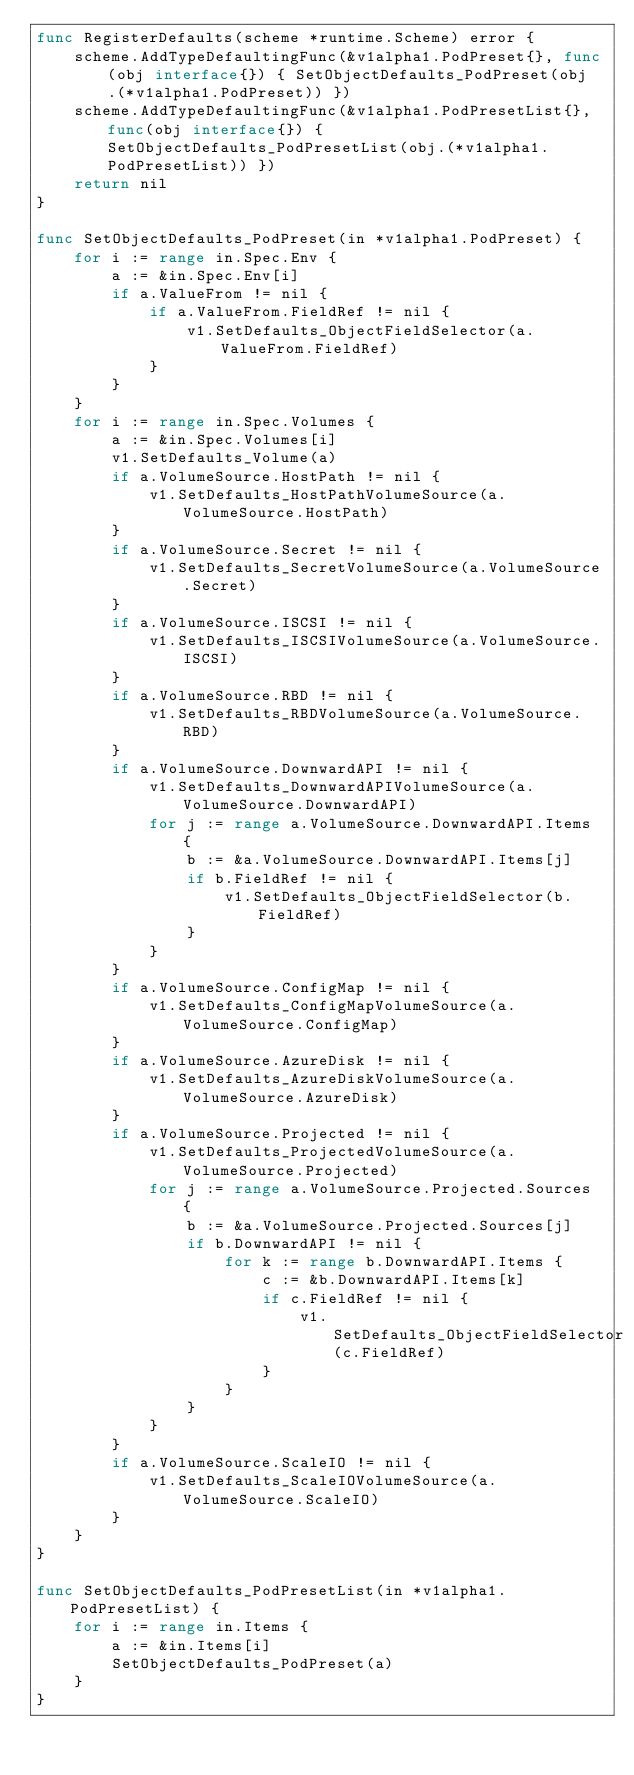Convert code to text. <code><loc_0><loc_0><loc_500><loc_500><_Go_>func RegisterDefaults(scheme *runtime.Scheme) error {
	scheme.AddTypeDefaultingFunc(&v1alpha1.PodPreset{}, func(obj interface{}) { SetObjectDefaults_PodPreset(obj.(*v1alpha1.PodPreset)) })
	scheme.AddTypeDefaultingFunc(&v1alpha1.PodPresetList{}, func(obj interface{}) { SetObjectDefaults_PodPresetList(obj.(*v1alpha1.PodPresetList)) })
	return nil
}

func SetObjectDefaults_PodPreset(in *v1alpha1.PodPreset) {
	for i := range in.Spec.Env {
		a := &in.Spec.Env[i]
		if a.ValueFrom != nil {
			if a.ValueFrom.FieldRef != nil {
				v1.SetDefaults_ObjectFieldSelector(a.ValueFrom.FieldRef)
			}
		}
	}
	for i := range in.Spec.Volumes {
		a := &in.Spec.Volumes[i]
		v1.SetDefaults_Volume(a)
		if a.VolumeSource.HostPath != nil {
			v1.SetDefaults_HostPathVolumeSource(a.VolumeSource.HostPath)
		}
		if a.VolumeSource.Secret != nil {
			v1.SetDefaults_SecretVolumeSource(a.VolumeSource.Secret)
		}
		if a.VolumeSource.ISCSI != nil {
			v1.SetDefaults_ISCSIVolumeSource(a.VolumeSource.ISCSI)
		}
		if a.VolumeSource.RBD != nil {
			v1.SetDefaults_RBDVolumeSource(a.VolumeSource.RBD)
		}
		if a.VolumeSource.DownwardAPI != nil {
			v1.SetDefaults_DownwardAPIVolumeSource(a.VolumeSource.DownwardAPI)
			for j := range a.VolumeSource.DownwardAPI.Items {
				b := &a.VolumeSource.DownwardAPI.Items[j]
				if b.FieldRef != nil {
					v1.SetDefaults_ObjectFieldSelector(b.FieldRef)
				}
			}
		}
		if a.VolumeSource.ConfigMap != nil {
			v1.SetDefaults_ConfigMapVolumeSource(a.VolumeSource.ConfigMap)
		}
		if a.VolumeSource.AzureDisk != nil {
			v1.SetDefaults_AzureDiskVolumeSource(a.VolumeSource.AzureDisk)
		}
		if a.VolumeSource.Projected != nil {
			v1.SetDefaults_ProjectedVolumeSource(a.VolumeSource.Projected)
			for j := range a.VolumeSource.Projected.Sources {
				b := &a.VolumeSource.Projected.Sources[j]
				if b.DownwardAPI != nil {
					for k := range b.DownwardAPI.Items {
						c := &b.DownwardAPI.Items[k]
						if c.FieldRef != nil {
							v1.SetDefaults_ObjectFieldSelector(c.FieldRef)
						}
					}
				}
			}
		}
		if a.VolumeSource.ScaleIO != nil {
			v1.SetDefaults_ScaleIOVolumeSource(a.VolumeSource.ScaleIO)
		}
	}
}

func SetObjectDefaults_PodPresetList(in *v1alpha1.PodPresetList) {
	for i := range in.Items {
		a := &in.Items[i]
		SetObjectDefaults_PodPreset(a)
	}
}
</code> 